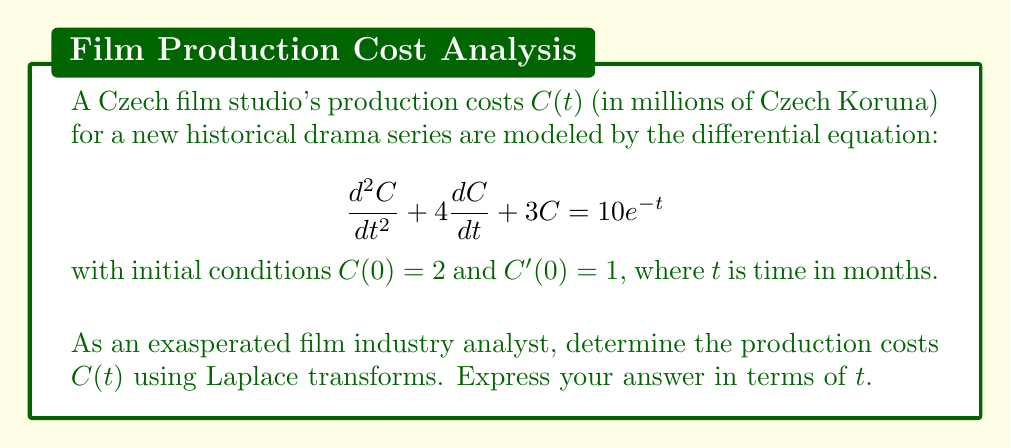Give your solution to this math problem. Let's solve this step-by-step using Laplace transforms:

1) Take the Laplace transform of both sides of the equation:
   $$\mathcal{L}\left\{\frac{d^2C}{dt^2} + 4\frac{dC}{dt} + 3C\right\} = \mathcal{L}\{10e^{-t}\}$$

2) Using Laplace transform properties:
   $$(s^2C(s) - sC(0) - C'(0)) + 4(sC(s) - C(0)) + 3C(s) = \frac{10}{s+1}$$

3) Substitute the initial conditions $C(0) = 2$ and $C'(0) = 1$:
   $$(s^2C(s) - 2s - 1) + 4(sC(s) - 2) + 3C(s) = \frac{10}{s+1}$$

4) Simplify:
   $$s^2C(s) + 4sC(s) + 3C(s) - 2s - 1 - 8 + \frac{10}{s+1} = 0$$
   $$(s^2 + 4s + 3)C(s) = 2s + 9 + \frac{10}{s+1}$$

5) Solve for $C(s)$:
   $$C(s) = \frac{2s + 9}{s^2 + 4s + 3} + \frac{10}{(s^2 + 4s + 3)(s+1)}$$

6) Decompose into partial fractions:
   $$C(s) = \frac{A}{s+1} + \frac{B}{s+3} + \frac{D}{s+1}$$
   where $A = 1$, $B = 1$, and $D = 5$

7) Take the inverse Laplace transform:
   $$C(t) = e^{-t} + e^{-3t} + 5te^{-t}$$

8) Simplify:
   $$C(t) = (1 + 5t)e^{-t} + e^{-3t}$$
Answer: $C(t) = (1 + 5t)e^{-t} + e^{-3t}$ 